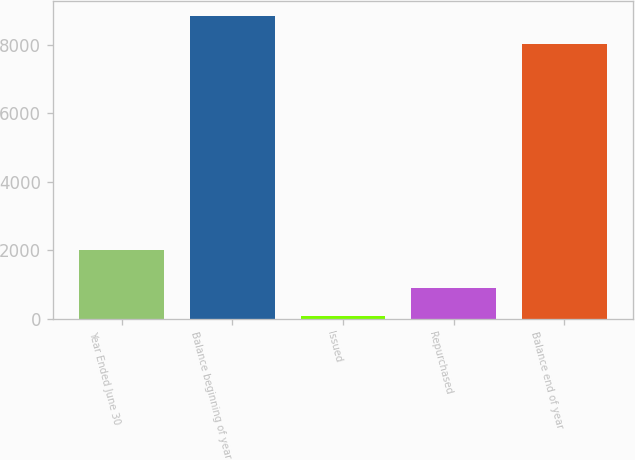Convert chart to OTSL. <chart><loc_0><loc_0><loc_500><loc_500><bar_chart><fcel>Year Ended June 30<fcel>Balance beginning of year<fcel>Issued<fcel>Repurchased<fcel>Balance end of year<nl><fcel>2015<fcel>8842.6<fcel>83<fcel>898.6<fcel>8027<nl></chart> 